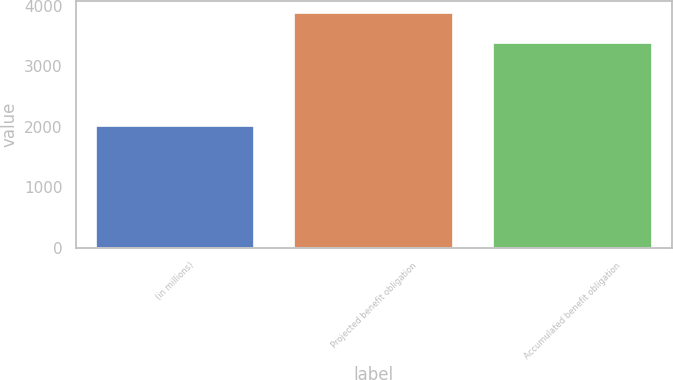<chart> <loc_0><loc_0><loc_500><loc_500><bar_chart><fcel>(in millions)<fcel>Projected benefit obligation<fcel>Accumulated benefit obligation<nl><fcel>2010<fcel>3878<fcel>3388<nl></chart> 